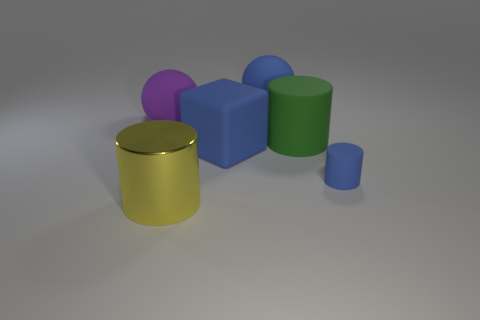Subtract all blue matte cylinders. How many cylinders are left? 2 Subtract all purple balls. How many balls are left? 1 Subtract all spheres. How many objects are left? 4 Add 2 yellow metal objects. How many yellow metal objects exist? 3 Add 3 purple things. How many objects exist? 9 Subtract 0 green blocks. How many objects are left? 6 Subtract 2 cylinders. How many cylinders are left? 1 Subtract all blue spheres. Subtract all yellow blocks. How many spheres are left? 1 Subtract all gray cubes. How many blue cylinders are left? 1 Subtract all metal objects. Subtract all tiny cyan metallic spheres. How many objects are left? 5 